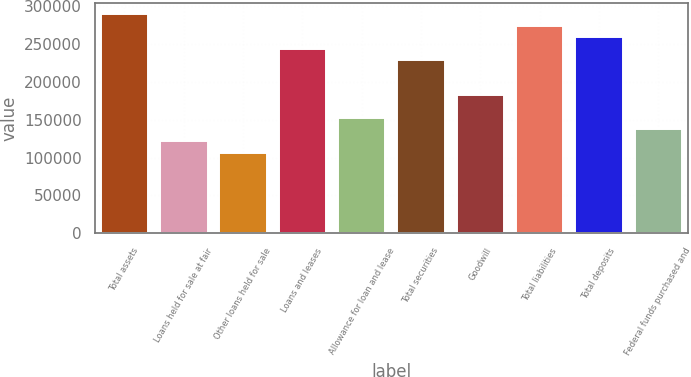<chart> <loc_0><loc_0><loc_500><loc_500><bar_chart><fcel>Total assets<fcel>Loans held for sale at fair<fcel>Other loans held for sale<fcel>Loans and leases<fcel>Allowance for loan and lease<fcel>Total securities<fcel>Goodwill<fcel>Total liabilities<fcel>Total deposits<fcel>Federal funds purchased and<nl><fcel>289438<fcel>121869<fcel>106635<fcel>243737<fcel>152336<fcel>228504<fcel>182803<fcel>274204<fcel>258971<fcel>137102<nl></chart> 